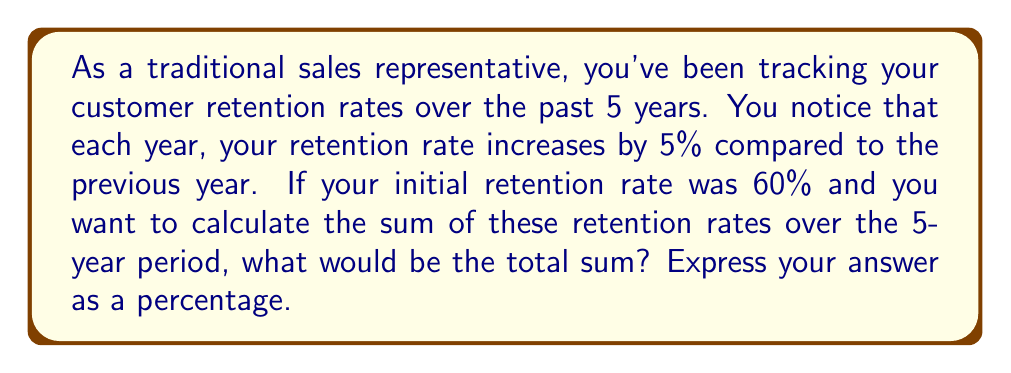Provide a solution to this math problem. Let's approach this step-by-step:

1) We have a geometric series where:
   - The first term, $a = 60\%$ (initial retention rate)
   - The common ratio, $r = 1.05$ (5% increase each year)
   - The number of terms, $n = 5$ (5-year period)

2) The formula for the sum of a geometric series is:

   $$S_n = \frac{a(1-r^n)}{1-r}$$

   Where $S_n$ is the sum of the series, $a$ is the first term, $r$ is the common ratio, and $n$ is the number of terms.

3) Let's substitute our values:

   $$S_5 = \frac{0.60(1-1.05^5)}{1-1.05}$$

4) Calculate $1.05^5$:
   
   $$1.05^5 \approx 1.2762815625$$

5) Now, let's solve the numerator and denominator separately:

   Numerator: $0.60(1-1.2762815625) = 0.60(-0.2762815625) = -0.1657689375$
   
   Denominator: $1-1.05 = -0.05$

6) Divide:

   $$S_5 = \frac{-0.1657689375}{-0.05} = 3.3153787500$$

7) Convert to percentage:

   $3.3153787500 * 100\% = 331.54\%$
Answer: The sum of the retention rates over the 5-year period is approximately 331.54%. 